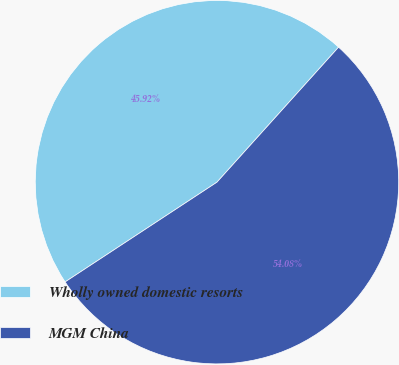<chart> <loc_0><loc_0><loc_500><loc_500><pie_chart><fcel>Wholly owned domestic resorts<fcel>MGM China<nl><fcel>45.92%<fcel>54.08%<nl></chart> 